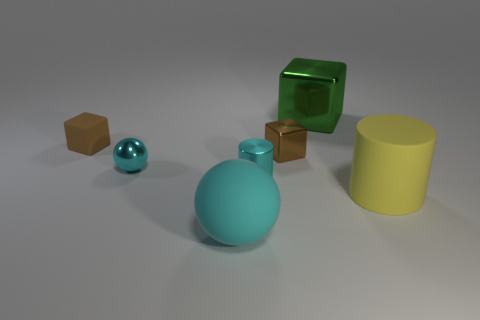There is a cyan sphere that is made of the same material as the big yellow cylinder; what size is it? The cyan sphere appears to be medium in size when compared to the other objects in the image, such as the large yellow cylinder and the smaller geometric shapes. Despite being made of the same glossy material as the big yellow cylinder, its size is more reminiscent of the turquoise sphere, suggesting a comparison in volume rather than surface area. 